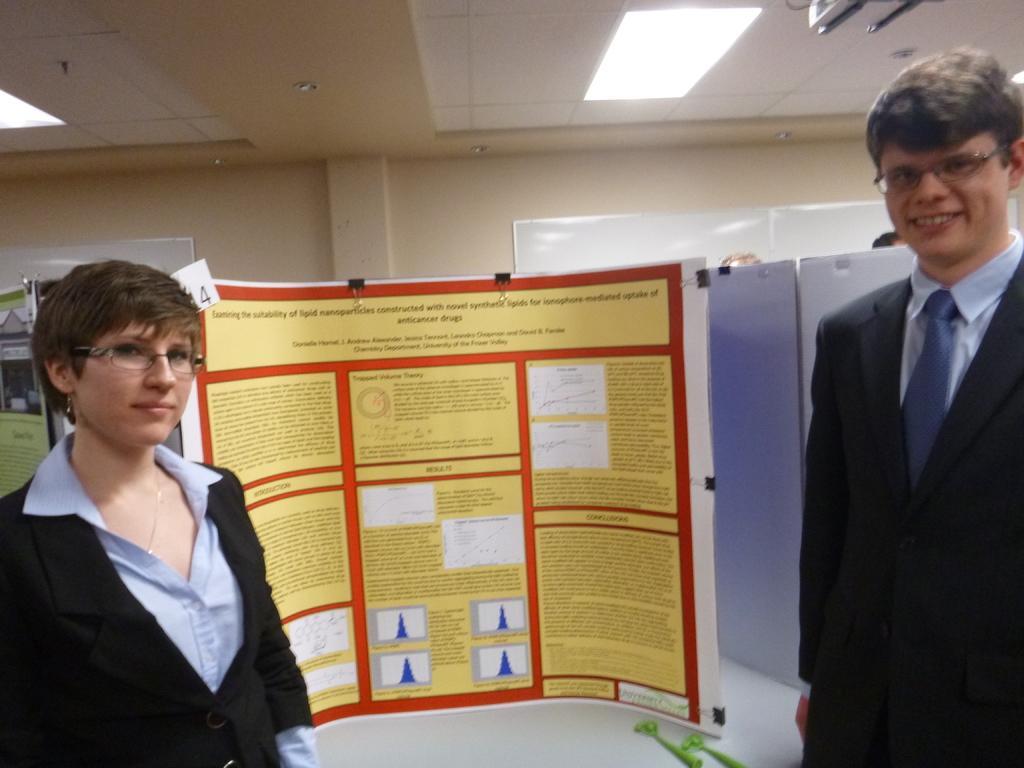Could you give a brief overview of what you see in this image? In the image we can see there are people standing and behind them there is a banner sheet kept on the table. 